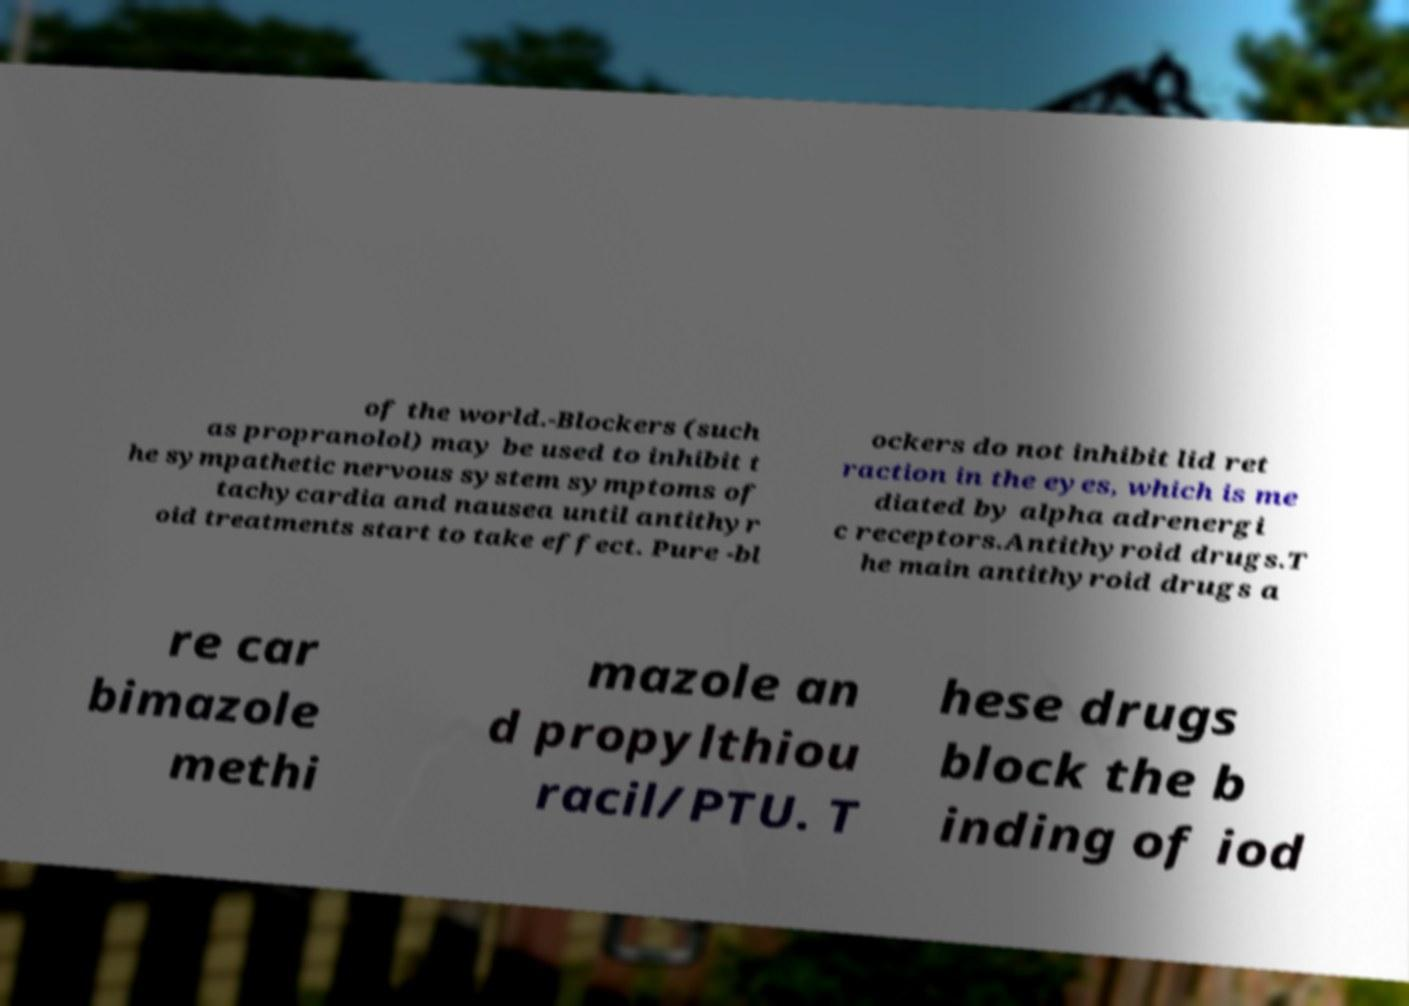For documentation purposes, I need the text within this image transcribed. Could you provide that? of the world.-Blockers (such as propranolol) may be used to inhibit t he sympathetic nervous system symptoms of tachycardia and nausea until antithyr oid treatments start to take effect. Pure -bl ockers do not inhibit lid ret raction in the eyes, which is me diated by alpha adrenergi c receptors.Antithyroid drugs.T he main antithyroid drugs a re car bimazole methi mazole an d propylthiou racil/PTU. T hese drugs block the b inding of iod 